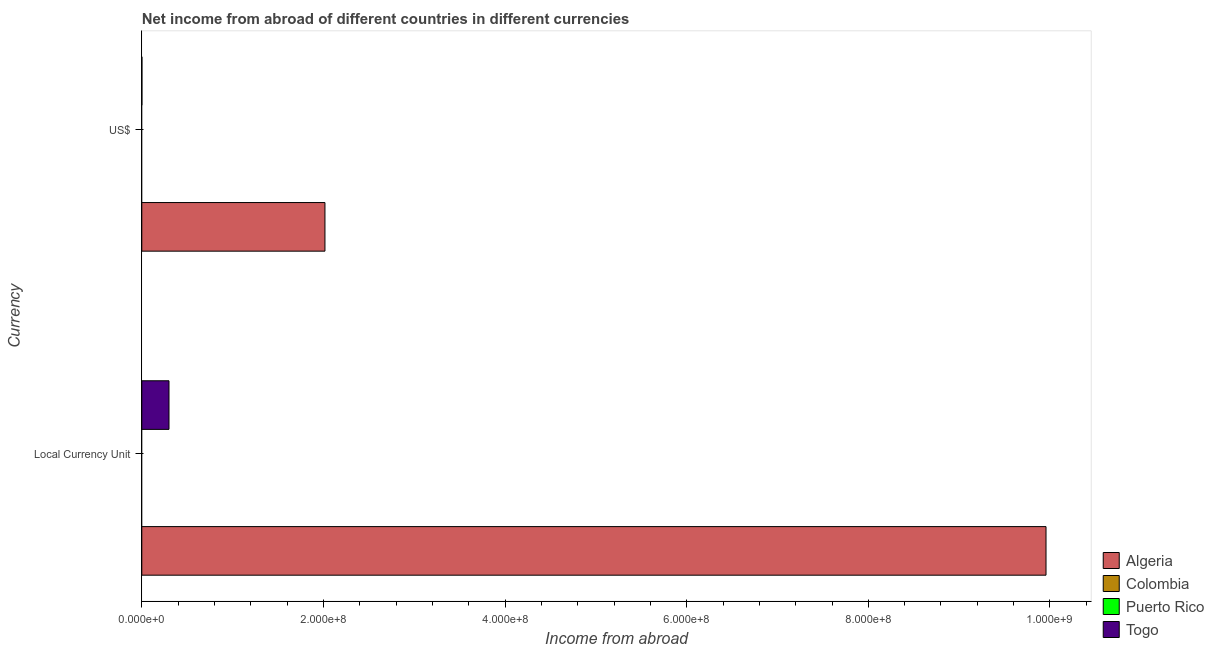Are the number of bars on each tick of the Y-axis equal?
Ensure brevity in your answer.  Yes. How many bars are there on the 2nd tick from the top?
Provide a short and direct response. 2. What is the label of the 1st group of bars from the top?
Your answer should be very brief. US$. What is the income from abroad in constant 2005 us$ in Togo?
Ensure brevity in your answer.  3.00e+07. Across all countries, what is the maximum income from abroad in us$?
Keep it short and to the point. 2.02e+08. Across all countries, what is the minimum income from abroad in us$?
Your response must be concise. 0. In which country was the income from abroad in us$ maximum?
Keep it short and to the point. Algeria. What is the total income from abroad in constant 2005 us$ in the graph?
Offer a very short reply. 1.03e+09. What is the difference between the income from abroad in us$ in Colombia and the income from abroad in constant 2005 us$ in Togo?
Offer a very short reply. -3.00e+07. What is the average income from abroad in constant 2005 us$ per country?
Offer a terse response. 2.56e+08. What is the difference between the income from abroad in us$ and income from abroad in constant 2005 us$ in Togo?
Offer a very short reply. -2.98e+07. In how many countries, is the income from abroad in constant 2005 us$ greater than 480000000 units?
Provide a succinct answer. 1. Is the income from abroad in us$ in Algeria less than that in Togo?
Make the answer very short. No. In how many countries, is the income from abroad in us$ greater than the average income from abroad in us$ taken over all countries?
Your answer should be very brief. 1. Are all the bars in the graph horizontal?
Your answer should be compact. Yes. How many countries are there in the graph?
Provide a succinct answer. 4. Where does the legend appear in the graph?
Offer a very short reply. Bottom right. What is the title of the graph?
Provide a succinct answer. Net income from abroad of different countries in different currencies. Does "Greece" appear as one of the legend labels in the graph?
Offer a terse response. No. What is the label or title of the X-axis?
Your response must be concise. Income from abroad. What is the label or title of the Y-axis?
Offer a terse response. Currency. What is the Income from abroad in Algeria in Local Currency Unit?
Your answer should be compact. 9.96e+08. What is the Income from abroad in Togo in Local Currency Unit?
Your answer should be compact. 3.00e+07. What is the Income from abroad in Algeria in US$?
Provide a succinct answer. 2.02e+08. What is the Income from abroad in Colombia in US$?
Give a very brief answer. 0. What is the Income from abroad in Puerto Rico in US$?
Keep it short and to the point. 0. What is the Income from abroad in Togo in US$?
Make the answer very short. 1.22e+05. Across all Currency, what is the maximum Income from abroad of Algeria?
Your response must be concise. 9.96e+08. Across all Currency, what is the maximum Income from abroad of Togo?
Offer a terse response. 3.00e+07. Across all Currency, what is the minimum Income from abroad in Algeria?
Provide a succinct answer. 2.02e+08. Across all Currency, what is the minimum Income from abroad of Togo?
Offer a very short reply. 1.22e+05. What is the total Income from abroad in Algeria in the graph?
Provide a succinct answer. 1.20e+09. What is the total Income from abroad of Togo in the graph?
Offer a terse response. 3.01e+07. What is the difference between the Income from abroad in Algeria in Local Currency Unit and that in US$?
Provide a succinct answer. 7.94e+08. What is the difference between the Income from abroad of Togo in Local Currency Unit and that in US$?
Offer a terse response. 2.98e+07. What is the difference between the Income from abroad of Algeria in Local Currency Unit and the Income from abroad of Togo in US$?
Ensure brevity in your answer.  9.96e+08. What is the average Income from abroad in Algeria per Currency?
Your answer should be very brief. 5.99e+08. What is the average Income from abroad in Colombia per Currency?
Ensure brevity in your answer.  0. What is the average Income from abroad of Puerto Rico per Currency?
Your answer should be compact. 0. What is the average Income from abroad in Togo per Currency?
Your response must be concise. 1.50e+07. What is the difference between the Income from abroad of Algeria and Income from abroad of Togo in Local Currency Unit?
Offer a very short reply. 9.66e+08. What is the difference between the Income from abroad in Algeria and Income from abroad in Togo in US$?
Offer a terse response. 2.02e+08. What is the ratio of the Income from abroad in Algeria in Local Currency Unit to that in US$?
Give a very brief answer. 4.94. What is the ratio of the Income from abroad of Togo in Local Currency Unit to that in US$?
Your answer should be very brief. 245.01. What is the difference between the highest and the second highest Income from abroad of Algeria?
Offer a very short reply. 7.94e+08. What is the difference between the highest and the second highest Income from abroad of Togo?
Provide a short and direct response. 2.98e+07. What is the difference between the highest and the lowest Income from abroad in Algeria?
Make the answer very short. 7.94e+08. What is the difference between the highest and the lowest Income from abroad in Togo?
Your response must be concise. 2.98e+07. 